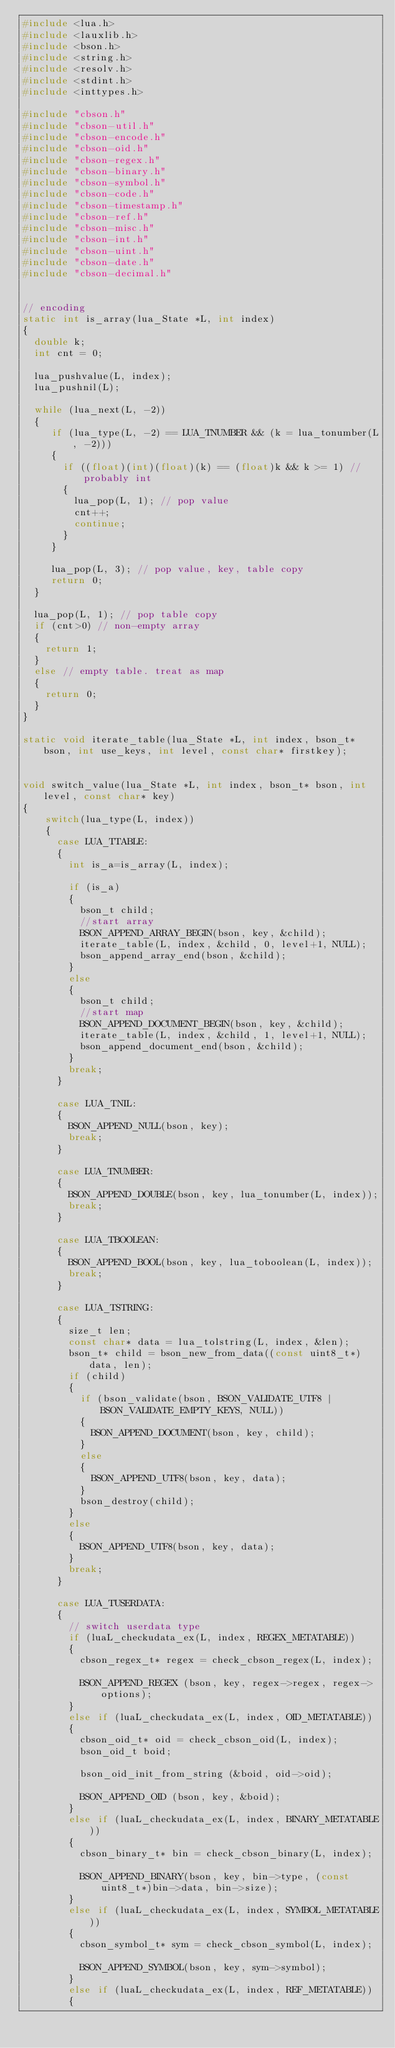Convert code to text. <code><loc_0><loc_0><loc_500><loc_500><_C_>#include <lua.h>
#include <lauxlib.h>
#include <bson.h>
#include <string.h>
#include <resolv.h>
#include <stdint.h>
#include <inttypes.h>

#include "cbson.h"
#include "cbson-util.h"
#include "cbson-encode.h"
#include "cbson-oid.h"
#include "cbson-regex.h"
#include "cbson-binary.h"
#include "cbson-symbol.h"
#include "cbson-code.h"
#include "cbson-timestamp.h"
#include "cbson-ref.h"
#include "cbson-misc.h"
#include "cbson-int.h"
#include "cbson-uint.h"
#include "cbson-date.h"
#include "cbson-decimal.h"


// encoding
static int is_array(lua_State *L, int index)
{
  double k;
  int cnt = 0;

  lua_pushvalue(L, index);
  lua_pushnil(L);

  while (lua_next(L, -2))
  {
     if (lua_type(L, -2) == LUA_TNUMBER && (k = lua_tonumber(L, -2)))
     {
       if ((float)(int)(float)(k) == (float)k && k >= 1) // probably int
       {
         lua_pop(L, 1); // pop value
         cnt++;
         continue;
       }
     }

     lua_pop(L, 3); // pop value, key, table copy
     return 0;
  }

  lua_pop(L, 1); // pop table copy
  if (cnt>0) // non-empty array
  {
    return 1;
  }
  else // empty table. treat as map
  {
    return 0;
  }
}

static void iterate_table(lua_State *L, int index, bson_t* bson, int use_keys, int level, const char* firstkey);


void switch_value(lua_State *L, int index, bson_t* bson, int level, const char* key)
{
    switch(lua_type(L, index))
    {
      case LUA_TTABLE:
      {
        int is_a=is_array(L, index);

        if (is_a)
        {
          bson_t child;
          //start array
          BSON_APPEND_ARRAY_BEGIN(bson, key, &child);
          iterate_table(L, index, &child, 0, level+1, NULL);
          bson_append_array_end(bson, &child);
        }
        else
        {
          bson_t child;
          //start map
          BSON_APPEND_DOCUMENT_BEGIN(bson, key, &child);
          iterate_table(L, index, &child, 1, level+1, NULL);
          bson_append_document_end(bson, &child);
        }
        break;
      }

      case LUA_TNIL:
      {
        BSON_APPEND_NULL(bson, key);
        break;
      }

      case LUA_TNUMBER:
      {
        BSON_APPEND_DOUBLE(bson, key, lua_tonumber(L, index));
        break;
      }

      case LUA_TBOOLEAN:
      {
        BSON_APPEND_BOOL(bson, key, lua_toboolean(L, index));
        break;
      }

      case LUA_TSTRING:
      {
        size_t len;
        const char* data = lua_tolstring(L, index, &len);
        bson_t* child = bson_new_from_data((const uint8_t*)data, len);
        if (child)
        {
          if (bson_validate(bson, BSON_VALIDATE_UTF8 | BSON_VALIDATE_EMPTY_KEYS, NULL))
          {
            BSON_APPEND_DOCUMENT(bson, key, child);
          }
          else
          {
            BSON_APPEND_UTF8(bson, key, data);
          }
          bson_destroy(child);
        }
        else
        {
          BSON_APPEND_UTF8(bson, key, data);
        }
        break;
      }

      case LUA_TUSERDATA:
      {
        // switch userdata type
        if (luaL_checkudata_ex(L, index, REGEX_METATABLE))
        {
          cbson_regex_t* regex = check_cbson_regex(L, index);

          BSON_APPEND_REGEX (bson, key, regex->regex, regex->options);
        }
        else if (luaL_checkudata_ex(L, index, OID_METATABLE))
        {
          cbson_oid_t* oid = check_cbson_oid(L, index);
          bson_oid_t boid;

          bson_oid_init_from_string (&boid, oid->oid);

          BSON_APPEND_OID (bson, key, &boid);
        }
        else if (luaL_checkudata_ex(L, index, BINARY_METATABLE))
        {
          cbson_binary_t* bin = check_cbson_binary(L, index);

          BSON_APPEND_BINARY(bson, key, bin->type, (const uint8_t*)bin->data, bin->size);
        }
        else if (luaL_checkudata_ex(L, index, SYMBOL_METATABLE))
        {
          cbson_symbol_t* sym = check_cbson_symbol(L, index);

          BSON_APPEND_SYMBOL(bson, key, sym->symbol);
        }
        else if (luaL_checkudata_ex(L, index, REF_METATABLE))
        {</code> 